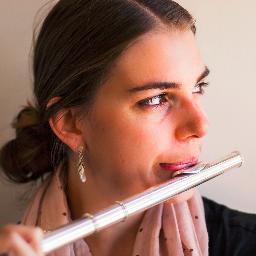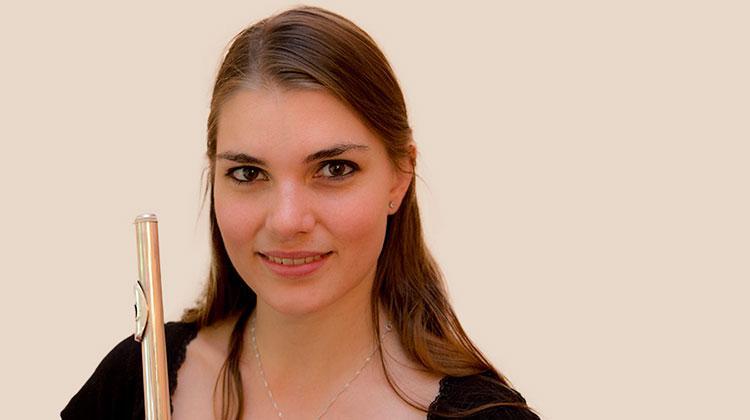The first image is the image on the left, the second image is the image on the right. Considering the images on both sides, is "One image shows a woman with a flute alongside her face on the left, and the other image shows a model with a flute horizontal to her mouth." valid? Answer yes or no. Yes. The first image is the image on the left, the second image is the image on the right. For the images shown, is this caption "One image shows a woman with a flute touching her mouth." true? Answer yes or no. Yes. 